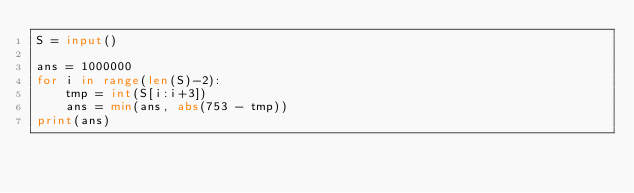<code> <loc_0><loc_0><loc_500><loc_500><_Python_>S = input()

ans = 1000000
for i in range(len(S)-2):
    tmp = int(S[i:i+3])
    ans = min(ans, abs(753 - tmp))
print(ans)
</code> 